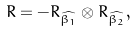Convert formula to latex. <formula><loc_0><loc_0><loc_500><loc_500>R = - R _ { \widehat { \beta _ { 1 } } } \otimes R _ { \widehat { \beta _ { 2 } } } ,</formula> 